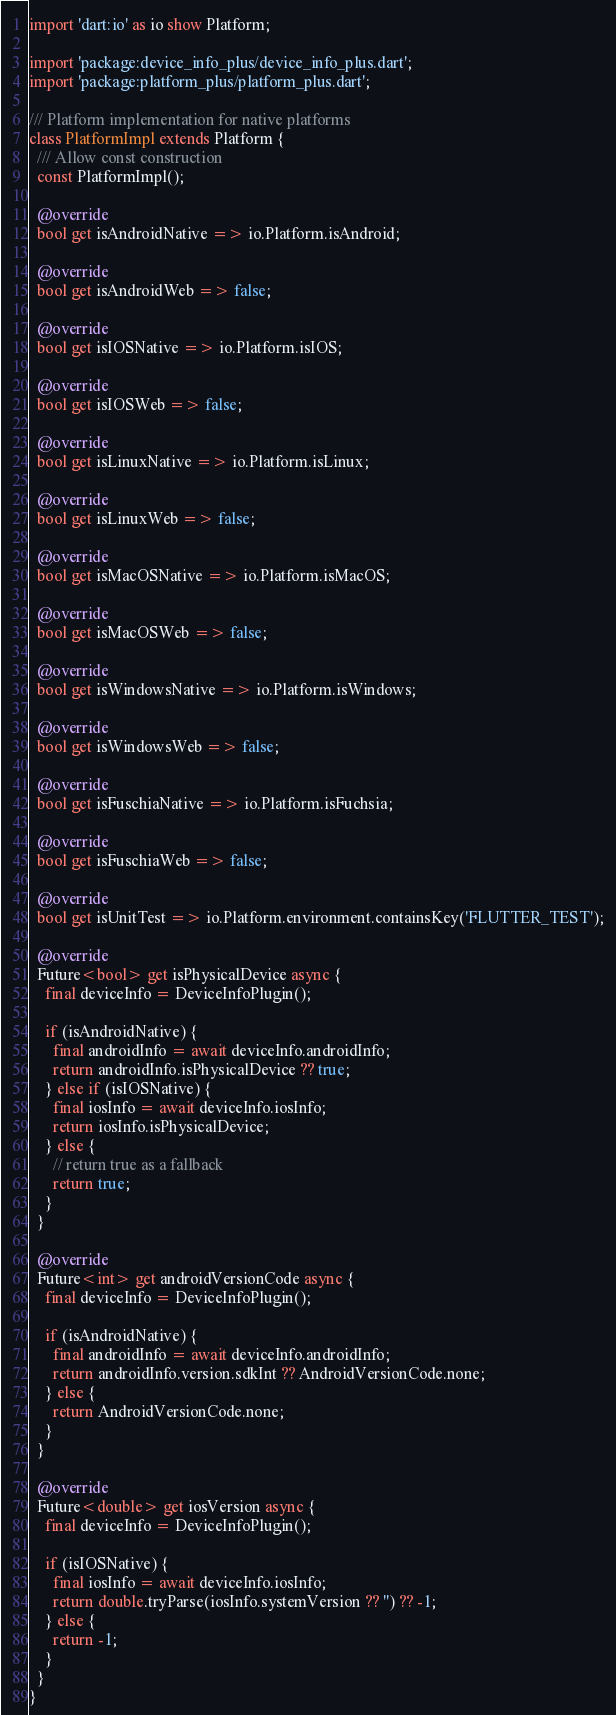Convert code to text. <code><loc_0><loc_0><loc_500><loc_500><_Dart_>import 'dart:io' as io show Platform;

import 'package:device_info_plus/device_info_plus.dart';
import 'package:platform_plus/platform_plus.dart';

/// Platform implementation for native platforms
class PlatformImpl extends Platform {
  /// Allow const construction
  const PlatformImpl();

  @override
  bool get isAndroidNative => io.Platform.isAndroid;

  @override
  bool get isAndroidWeb => false;

  @override
  bool get isIOSNative => io.Platform.isIOS;

  @override
  bool get isIOSWeb => false;

  @override
  bool get isLinuxNative => io.Platform.isLinux;

  @override
  bool get isLinuxWeb => false;

  @override
  bool get isMacOSNative => io.Platform.isMacOS;

  @override
  bool get isMacOSWeb => false;

  @override
  bool get isWindowsNative => io.Platform.isWindows;

  @override
  bool get isWindowsWeb => false;

  @override
  bool get isFuschiaNative => io.Platform.isFuchsia;

  @override
  bool get isFuschiaWeb => false;

  @override
  bool get isUnitTest => io.Platform.environment.containsKey('FLUTTER_TEST');

  @override
  Future<bool> get isPhysicalDevice async {
    final deviceInfo = DeviceInfoPlugin();

    if (isAndroidNative) {
      final androidInfo = await deviceInfo.androidInfo;
      return androidInfo.isPhysicalDevice ?? true;
    } else if (isIOSNative) {
      final iosInfo = await deviceInfo.iosInfo;
      return iosInfo.isPhysicalDevice;
    } else {
      // return true as a fallback
      return true;
    }
  }

  @override
  Future<int> get androidVersionCode async {
    final deviceInfo = DeviceInfoPlugin();

    if (isAndroidNative) {
      final androidInfo = await deviceInfo.androidInfo;
      return androidInfo.version.sdkInt ?? AndroidVersionCode.none;
    } else {
      return AndroidVersionCode.none;
    }
  }

  @override
  Future<double> get iosVersion async {
    final deviceInfo = DeviceInfoPlugin();

    if (isIOSNative) {
      final iosInfo = await deviceInfo.iosInfo;
      return double.tryParse(iosInfo.systemVersion ?? '') ?? -1;
    } else {
      return -1;
    }
  }
}
</code> 